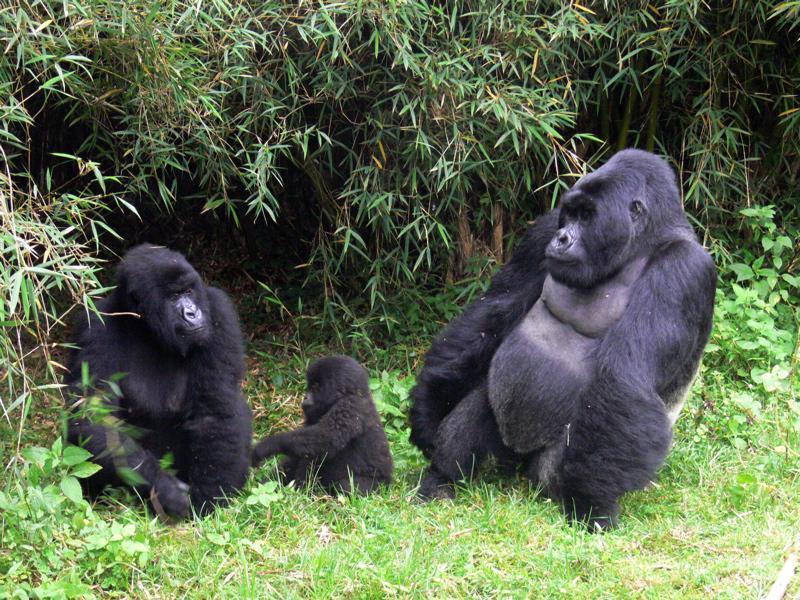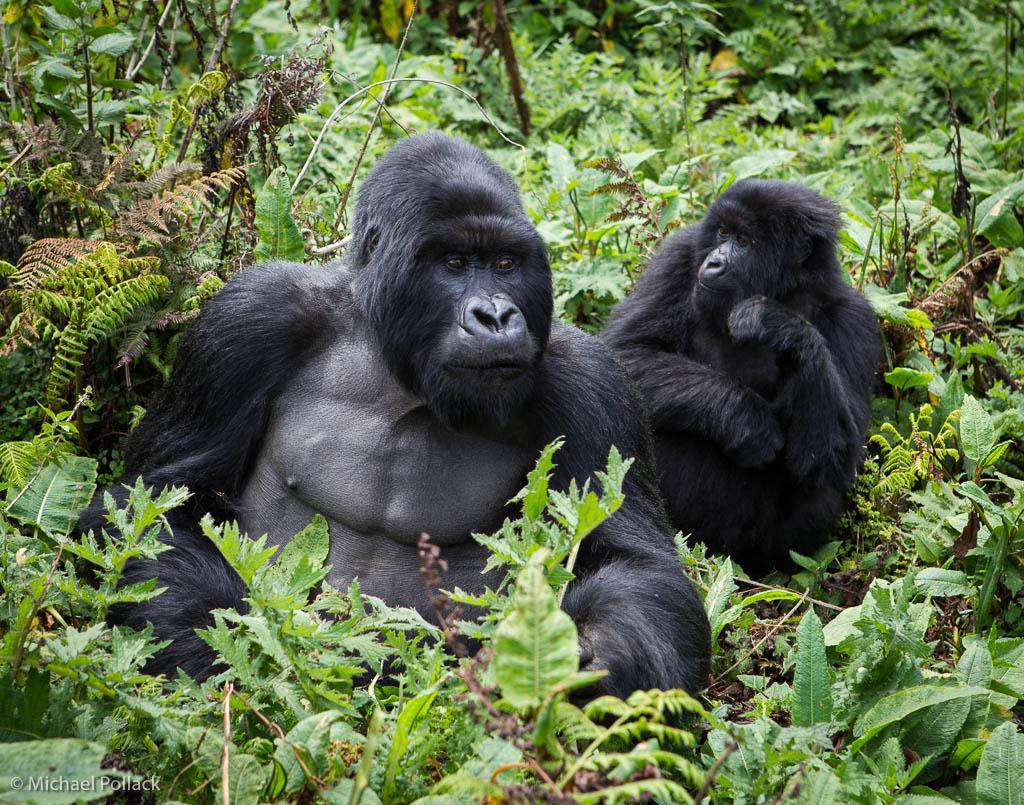The first image is the image on the left, the second image is the image on the right. For the images displayed, is the sentence "to the left, two simians appear to be playfully irritated at each other." factually correct? Answer yes or no. No. The first image is the image on the left, the second image is the image on the right. Assess this claim about the two images: "An image shows exactly two furry apes wrestling each other, both with wide-open mouths.". Correct or not? Answer yes or no. No. 